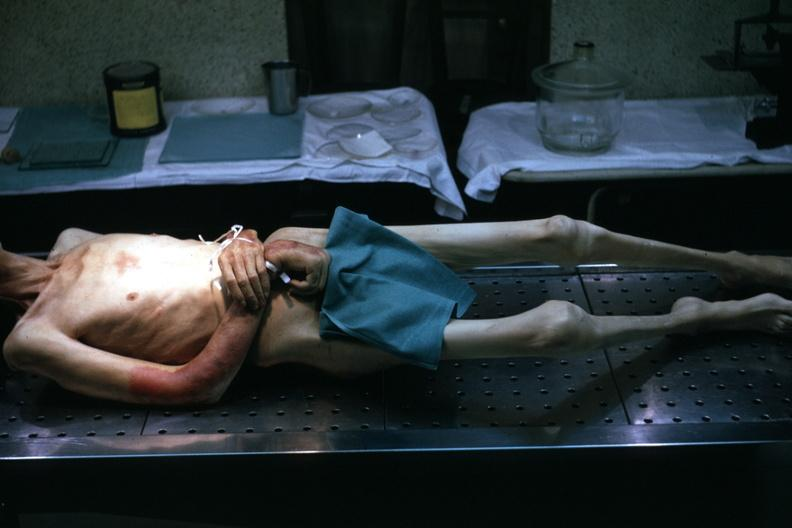what is present?
Answer the question using a single word or phrase. Cachexia 